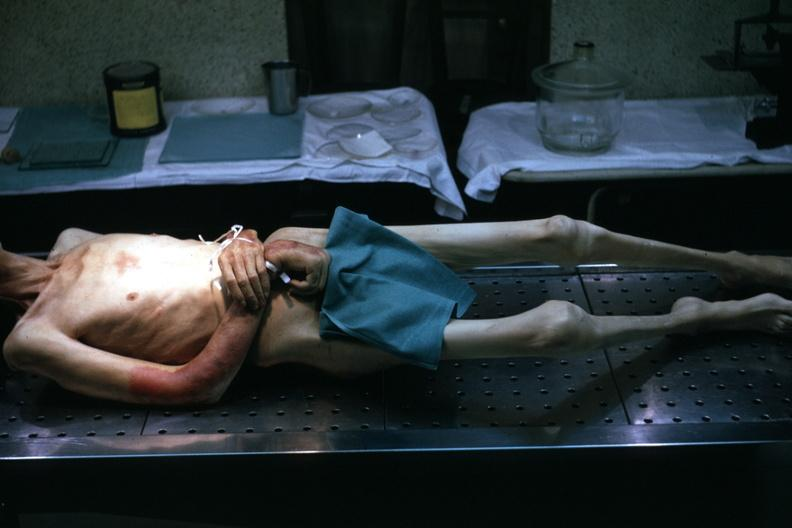what is present?
Answer the question using a single word or phrase. Cachexia 